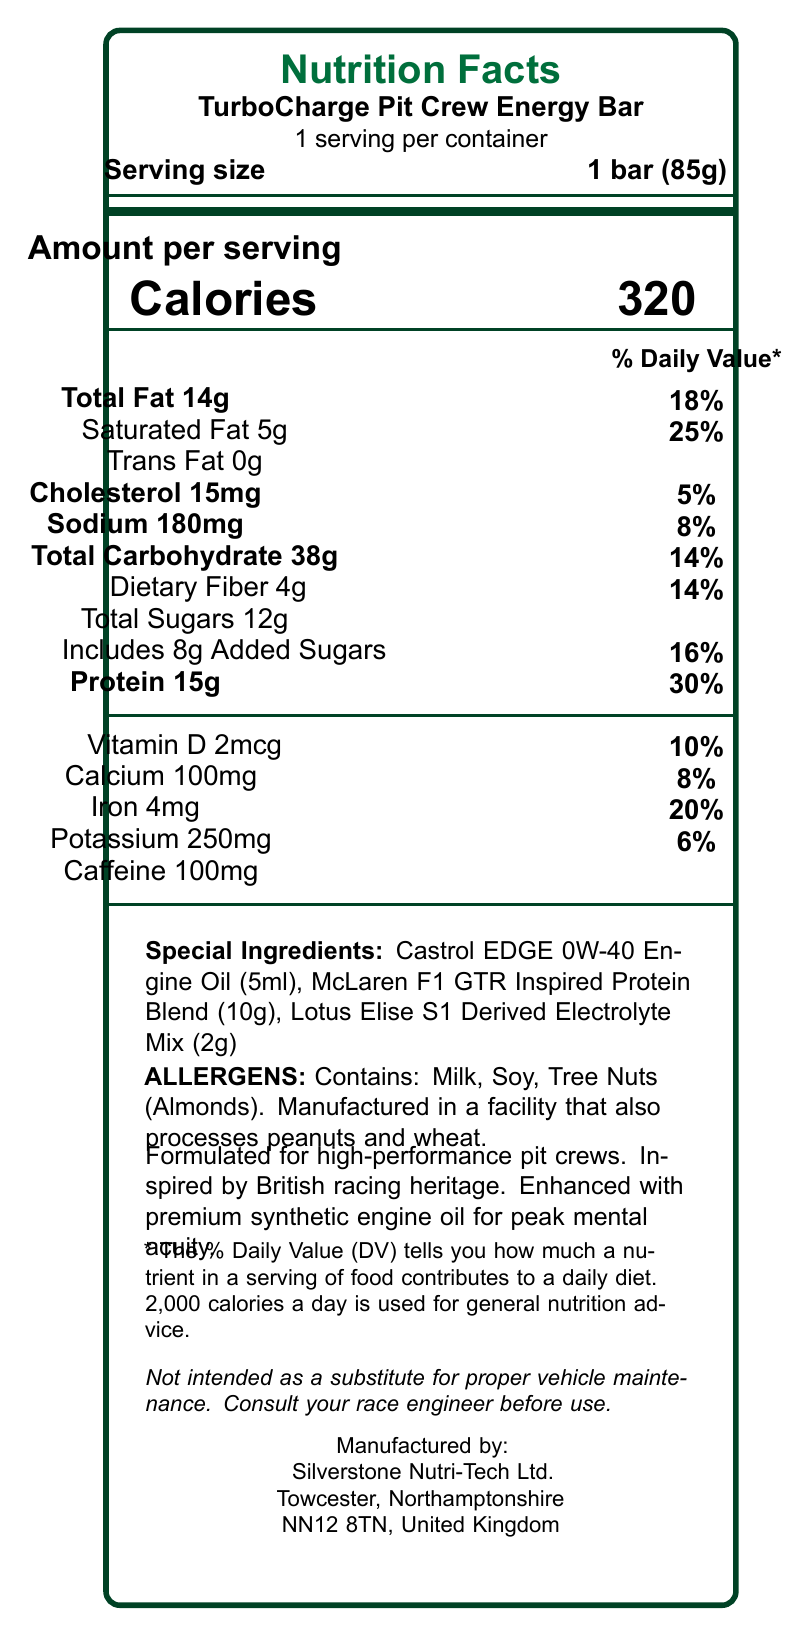What is the serving size of the TurboCharge Pit Crew Energy Bar? The serving size is listed as "1 bar (85g)" on the document.
Answer: 1 bar (85g) How many calories are in one serving of the TurboCharge Pit Crew Energy Bar? The document states that there are 320 calories per serving.
Answer: 320 calories Which special ingredient is included in the TurboCharge Pit Crew Energy Bar in a 5ml amount? The special ingredients section lists "Castrol EDGE 0W-40 Engine Oil (5ml)".
Answer: Castrol EDGE 0W-40 Engine Oil How much protein does the TurboCharge Pit Crew Energy Bar contain per serving? The amount of protein per serving is listed as 15g with a daily value of 30%.
Answer: 15g What is the daily value percentage of calcium in the TurboCharge Pit Crew Energy Bar? The document states that the daily value percentage for calcium is 8%.
Answer: 8% What is the amount of added sugars in the TurboCharge Pit Crew Energy Bar? The added sugars are listed as 8g, with a daily value of 16%.
Answer: 8g How many grams of dietary fiber are in the TurboCharge Pit Crew Energy Bar? The document indicates that one serving contains 4g of dietary fiber.
Answer: 4g Which of the following allergens are present in the TurboCharge Pit Crew Energy Bar?
A. Peanuts
B. Soy
C. Wheat
D. Tree Nuts (Almonds) The allergens section lists milk, soy, and tree nuts (almonds). Peanuts and wheat are processed in the facility but not directly in the bar.
Answer: B and D What is the total carbohydrate content in one serving of the energy bar? The document states that the total carbohydrate content is 38g with a daily value of 14%.
Answer: 38g True or False: The TurboCharge Pit Crew Energy Bar is inspired by British racing heritage. The claim statements include "Inspired by British racing heritage."
Answer: True What is the primary function as stated for the TurboCharge Pit Crew Energy Bar's inclusion of premium synthetic engine oil? The document states "Enhanced with premium synthetic engine oil for peak mental acuity" under claim statements.
Answer: Peak mental acuity Describe the main idea of the TurboCharge Pit Crew Energy Bar's nutrition facts label. The bar's high-performance features are emphasized through specialized ingredients, nutritional content, and claim statements related to racing and engineering support.
Answer: The TurboCharge Pit Crew Energy Bar is designed for mechanics and pit crew members, highlighted by its high protein content, special ingredients inspired by British car culture, and formulated for high-performance scenarios. It includes notable ingredients like Castrol EDGE Engine Oil and has significant amounts of protein, fiber, and caffeine to support mental and physical performance. Who is the manufacturer of the TurboCharge Pit Crew Energy Bar? The manufacturer information at the bottom lists "Silverstone Nutri-Tech Ltd." as the producer.
Answer: Silverstone Nutri-Tech Ltd. What is the total fat content as a percentage of daily value for this energy bar? The total fat content is listed as 14g, which corresponds to 18% of the daily value.
Answer: 18% What types of tree nuts are included in the ingredients? The allergens section specifies tree nuts (almonds).
Answer: Almonds How much caffeine is included in the TurboCharge Pit Crew Energy Bar? The document lists 100mg of caffeine.
Answer: 100mg What is the exact role of McLaren F1 GTR Inspired Protein Blend in the TurboCharge Pit Crew Energy Bar? The document lists the blend’s inclusion but does not specify its exact role or benefits.
Answer: Cannot be determined 